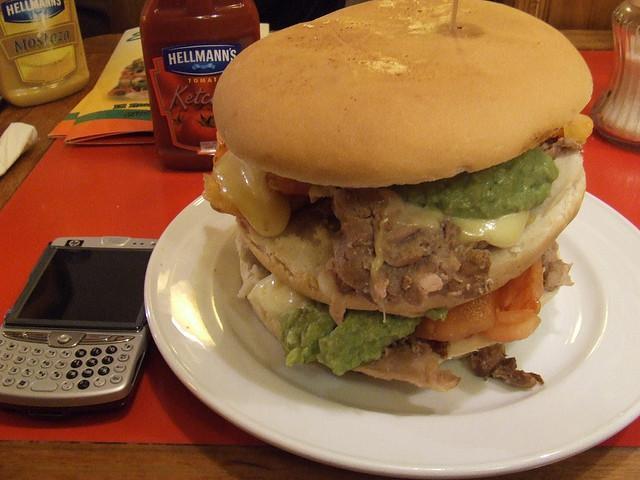How many bottles can you see?
Give a very brief answer. 2. 